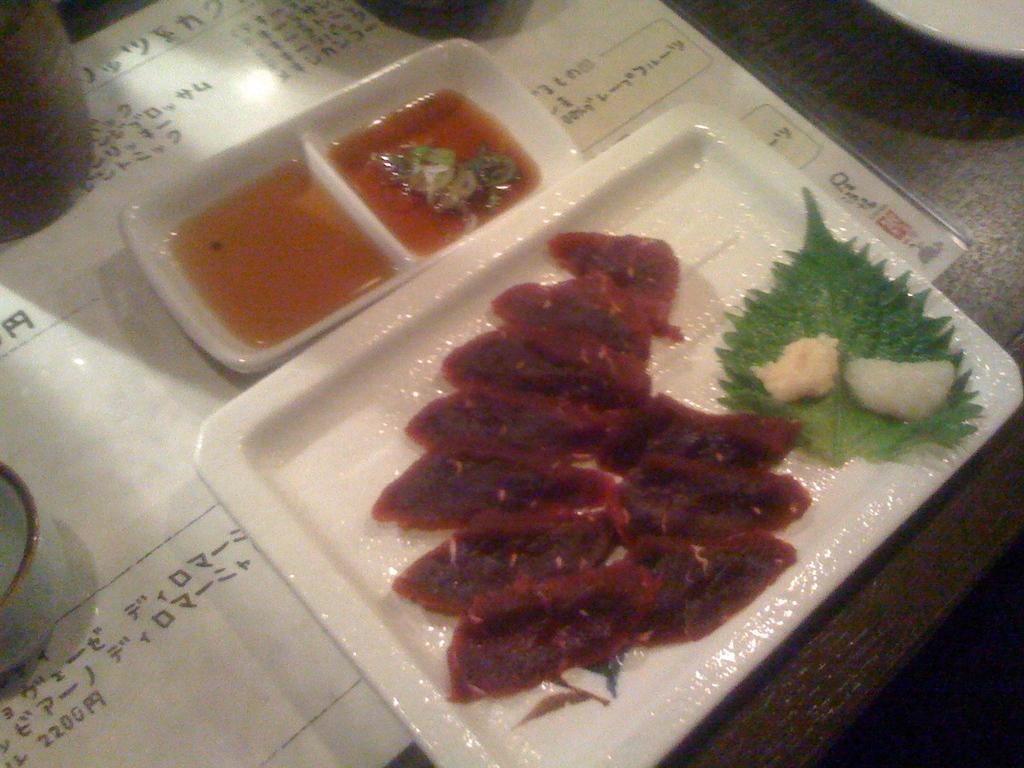Describe this image in one or two sentences. In the foreground of this image, there is some food on a platter and sauce in a cup like an object. On the table, there is a sheet, on which cup, platter and few objects are placed. 